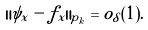<formula> <loc_0><loc_0><loc_500><loc_500>\| \psi _ { x } - f _ { x } \| _ { p _ { k } } = o _ { \delta } ( 1 ) .</formula> 